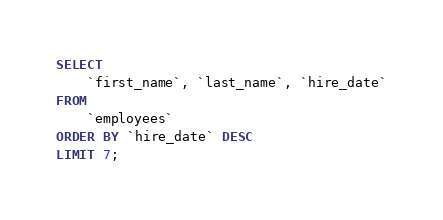<code> <loc_0><loc_0><loc_500><loc_500><_SQL_>SELECT 
    `first_name`, `last_name`, `hire_date`
FROM
    `employees`
ORDER BY `hire_date` DESC
LIMIT 7;</code> 